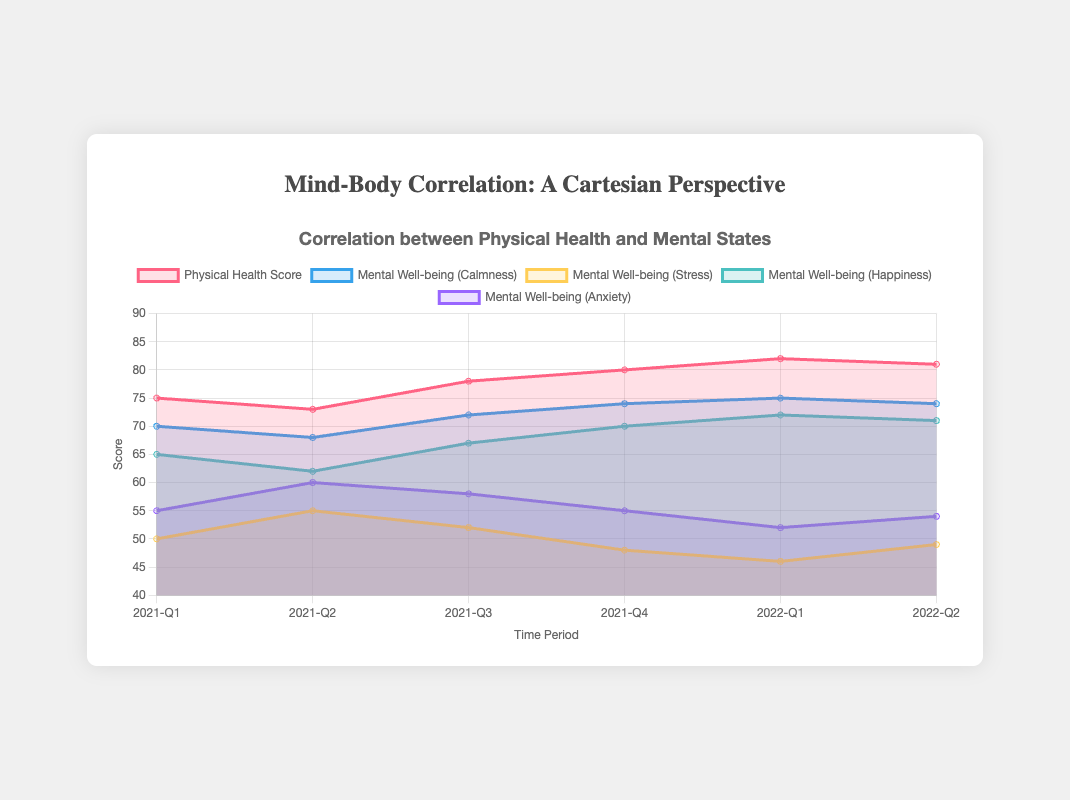What's the main title of the chart? The title is located at the top of the chart, usually in larger or bold font, summarizing its content.
Answer: Correlation between Physical Health and Mental States How many time periods are represented in the chart? The x-axis lists all the time periods, each representing a specific quarter-year segment. We can count these labels.
Answer: 6 Which mental state category seems to have the highest scores on average? We need to visually compare the overall heights of the areas for each mental state category and check their y-values. Happiness has the highest consistent values.
Answer: Happiness By how many points did the Physical Health Score increase from 2021-Q1 to 2022-Q1? Subtract the Physical Health Score at 2021-Q1 (75) from the score at 2022-Q1 (82).
Answer: 7 Which category experienced the maximum decrease in score between any two consecutive time periods? We need to check the score differences for all categories between every two consecutive periods. The largest visible drop is for Stress from 2021-Q2 to 2021-Q3 (55 -> 52).
Answer: Stress What is the trend of the Anxiety scores over the time periods? By looking at the graph’s area for Anxiety, we observe the score changes across time periods. First, it increases from Q1 to Q2 in 2021, then overall decreases with slight fluctuations.
Answer: Decreasing What was the score for Calmness in 2021-Q4? Locate the data point at 2021-Q4 for the Calmness mental state and note its y-value.
Answer: 74 How do the Stress and Anxiety scores compare in the final reporting period (2022-Q2)? Locate the final point for each category in 2022-Q2 and compare their y-values. Stress (49) and Anxiety (54).
Answer: Anxiety is higher What was the increase in Happiness from 2021-Q3 to 2022-Q1? Subtract the Happiness score in 2021-Q3 (67) from the score in 2022-Q1 (72).
Answer: 5 Which mental state had a lower score in 2022-Q1 compared to 2021-Q1? Compare the scores of each mental state between 2022-Q1 and 2021-Q1 and look for any decreases. Only Stress fulfills this criterion with scores 46 in 2022-Q1 and 50 in 2021-Q1.
Answer: Stress 